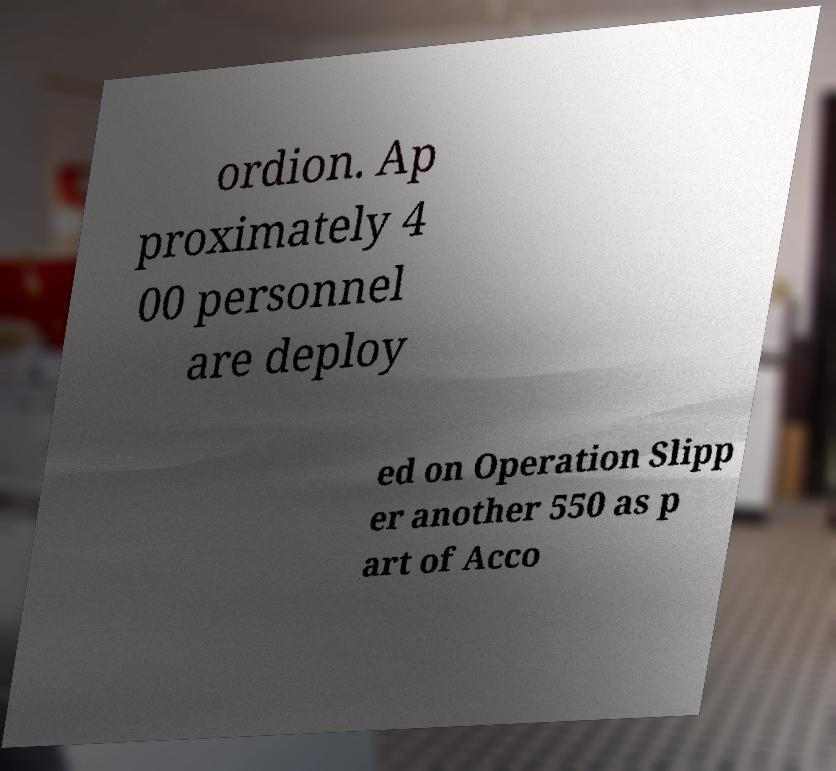Could you extract and type out the text from this image? ordion. Ap proximately 4 00 personnel are deploy ed on Operation Slipp er another 550 as p art of Acco 